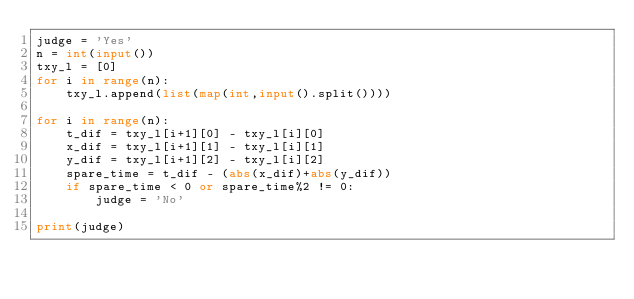<code> <loc_0><loc_0><loc_500><loc_500><_Python_>judge = 'Yes'
n = int(input())
txy_l = [0]
for i in range(n):
    txy_l.append(list(map(int,input().split())))

for i in range(n):
    t_dif = txy_l[i+1][0] - txy_l[i][0]
    x_dif = txy_l[i+1][1] - txy_l[i][1]
    y_dif = txy_l[i+1][2] - txy_l[i][2]
    spare_time = t_dif - (abs(x_dif)+abs(y_dif))
    if spare_time < 0 or spare_time%2 != 0:
        judge = 'No'

print(judge)</code> 